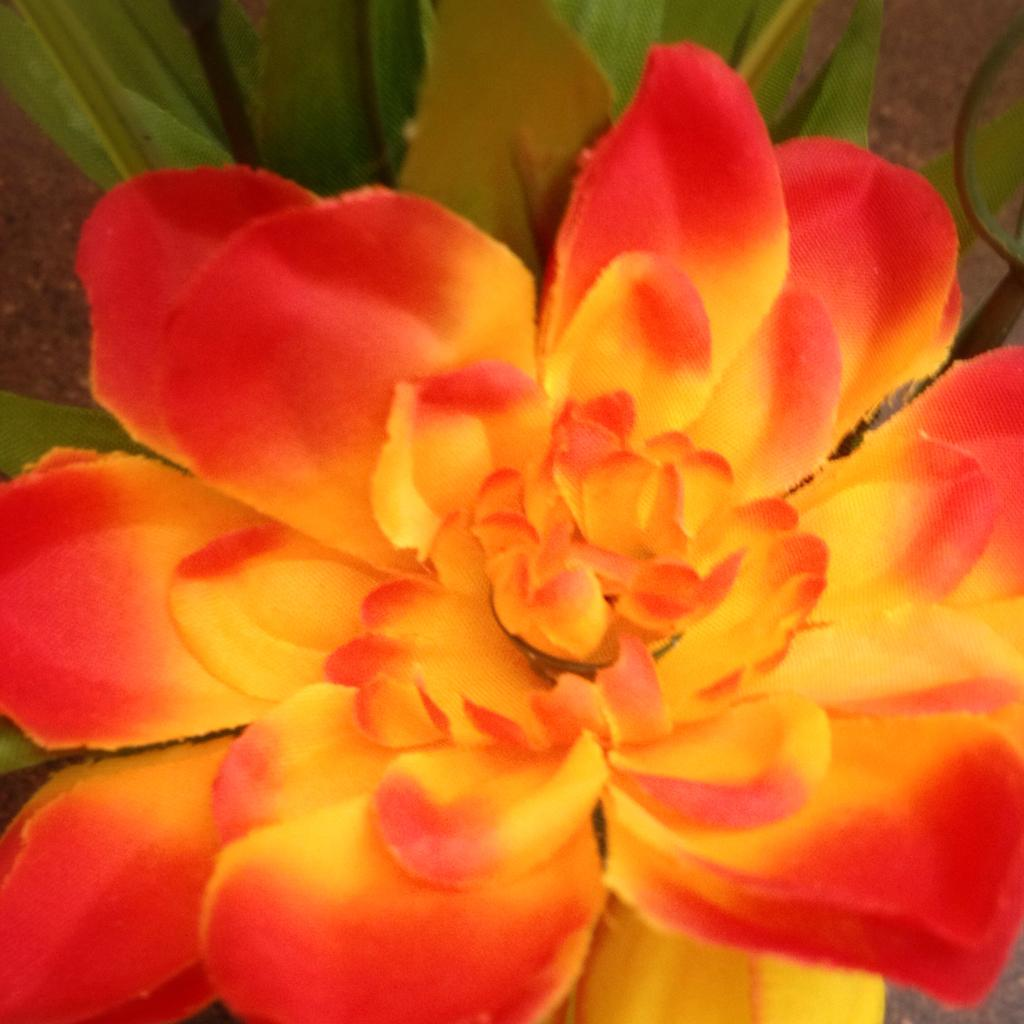What is the main subject of the picture? There is a flower in the picture. What can be seen in the background of the picture? There are leaves in the background of the picture. What invention is being demonstrated by the flower in the picture? There is no invention being demonstrated by the flower in the picture. How much waste is visible in the picture? There is no waste visible in the picture; it only features a flower and leaves. 